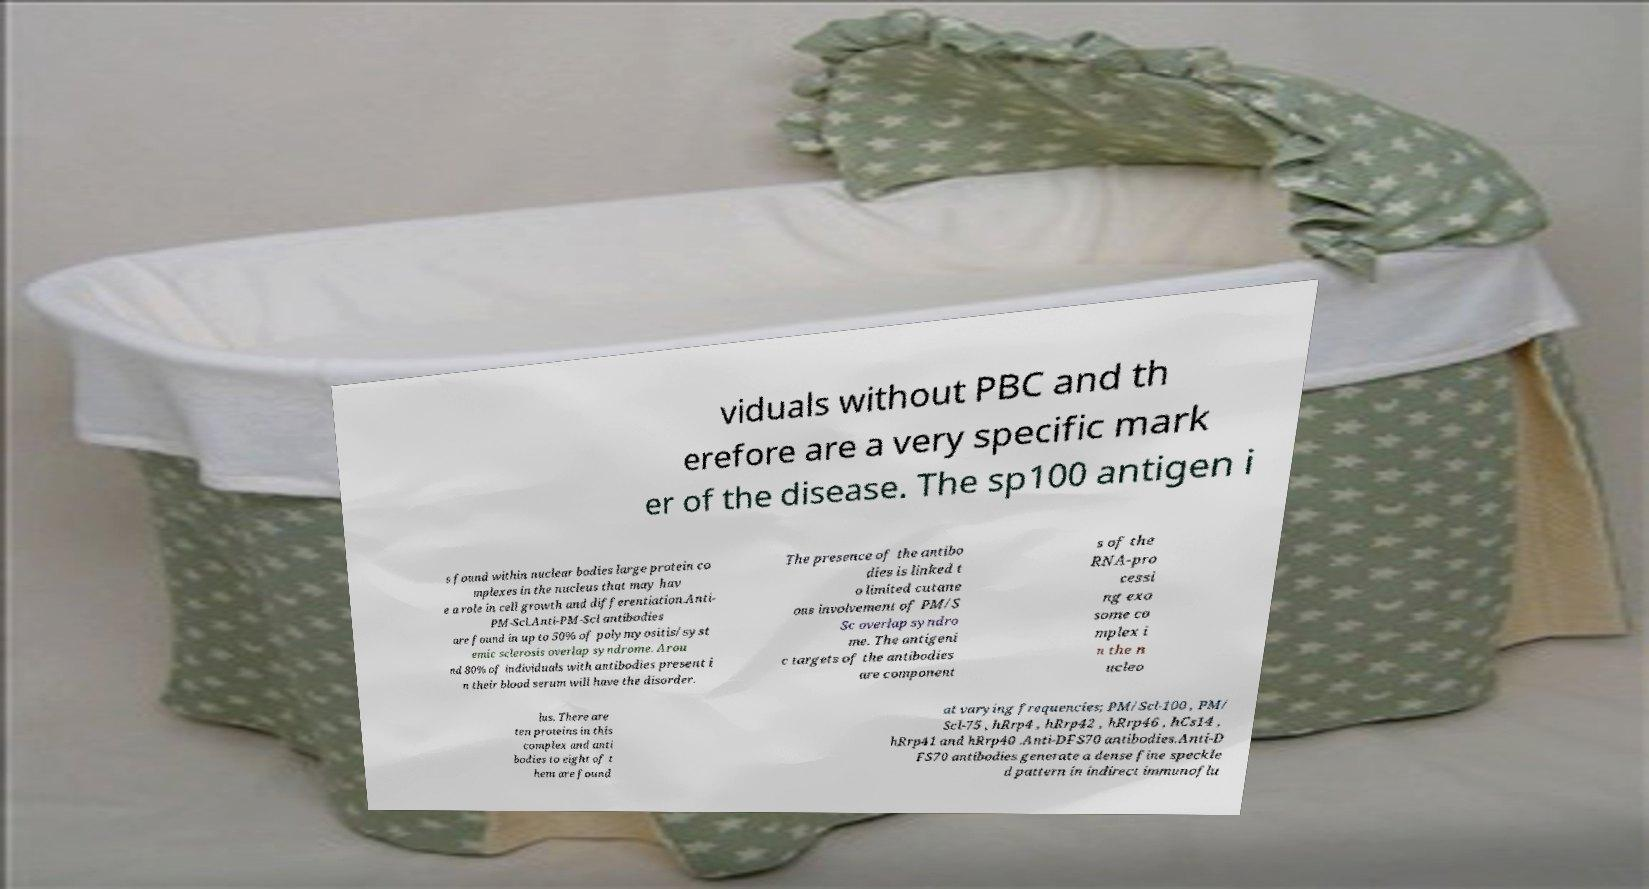Please identify and transcribe the text found in this image. viduals without PBC and th erefore are a very specific mark er of the disease. The sp100 antigen i s found within nuclear bodies large protein co mplexes in the nucleus that may hav e a role in cell growth and differentiation.Anti- PM-Scl.Anti-PM-Scl antibodies are found in up to 50% of polymyositis/syst emic sclerosis overlap syndrome. Arou nd 80% of individuals with antibodies present i n their blood serum will have the disorder. The presence of the antibo dies is linked t o limited cutane ous involvement of PM/S Sc overlap syndro me. The antigeni c targets of the antibodies are component s of the RNA-pro cessi ng exo some co mplex i n the n ucleo lus. There are ten proteins in this complex and anti bodies to eight of t hem are found at varying frequencies; PM/Scl-100 , PM/ Scl-75 , hRrp4 , hRrp42 , hRrp46 , hCs14 , hRrp41 and hRrp40 .Anti-DFS70 antibodies.Anti-D FS70 antibodies generate a dense fine speckle d pattern in indirect immunoflu 